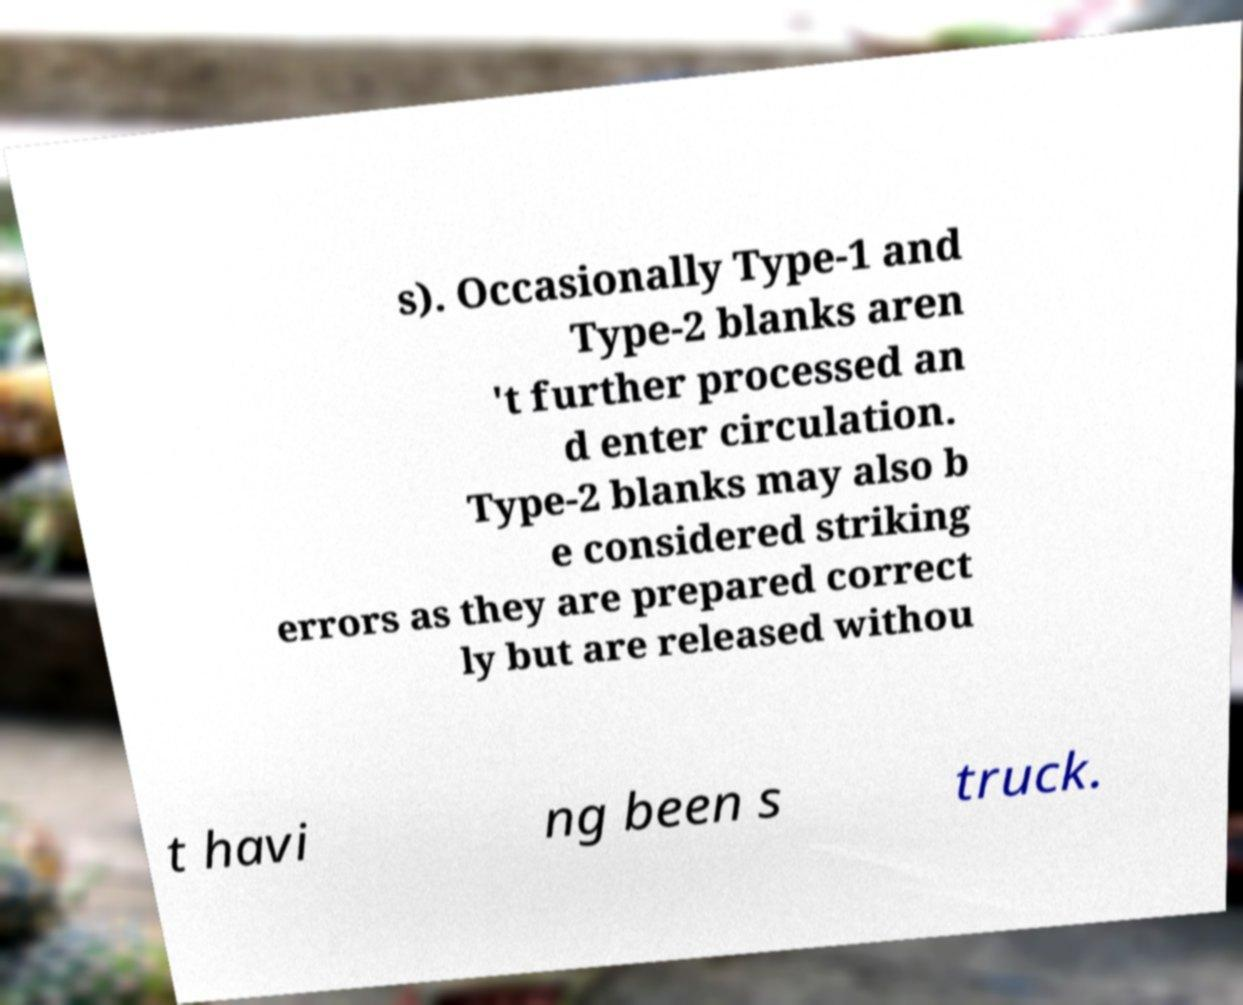There's text embedded in this image that I need extracted. Can you transcribe it verbatim? s). Occasionally Type-1 and Type-2 blanks aren 't further processed an d enter circulation. Type-2 blanks may also b e considered striking errors as they are prepared correct ly but are released withou t havi ng been s truck. 